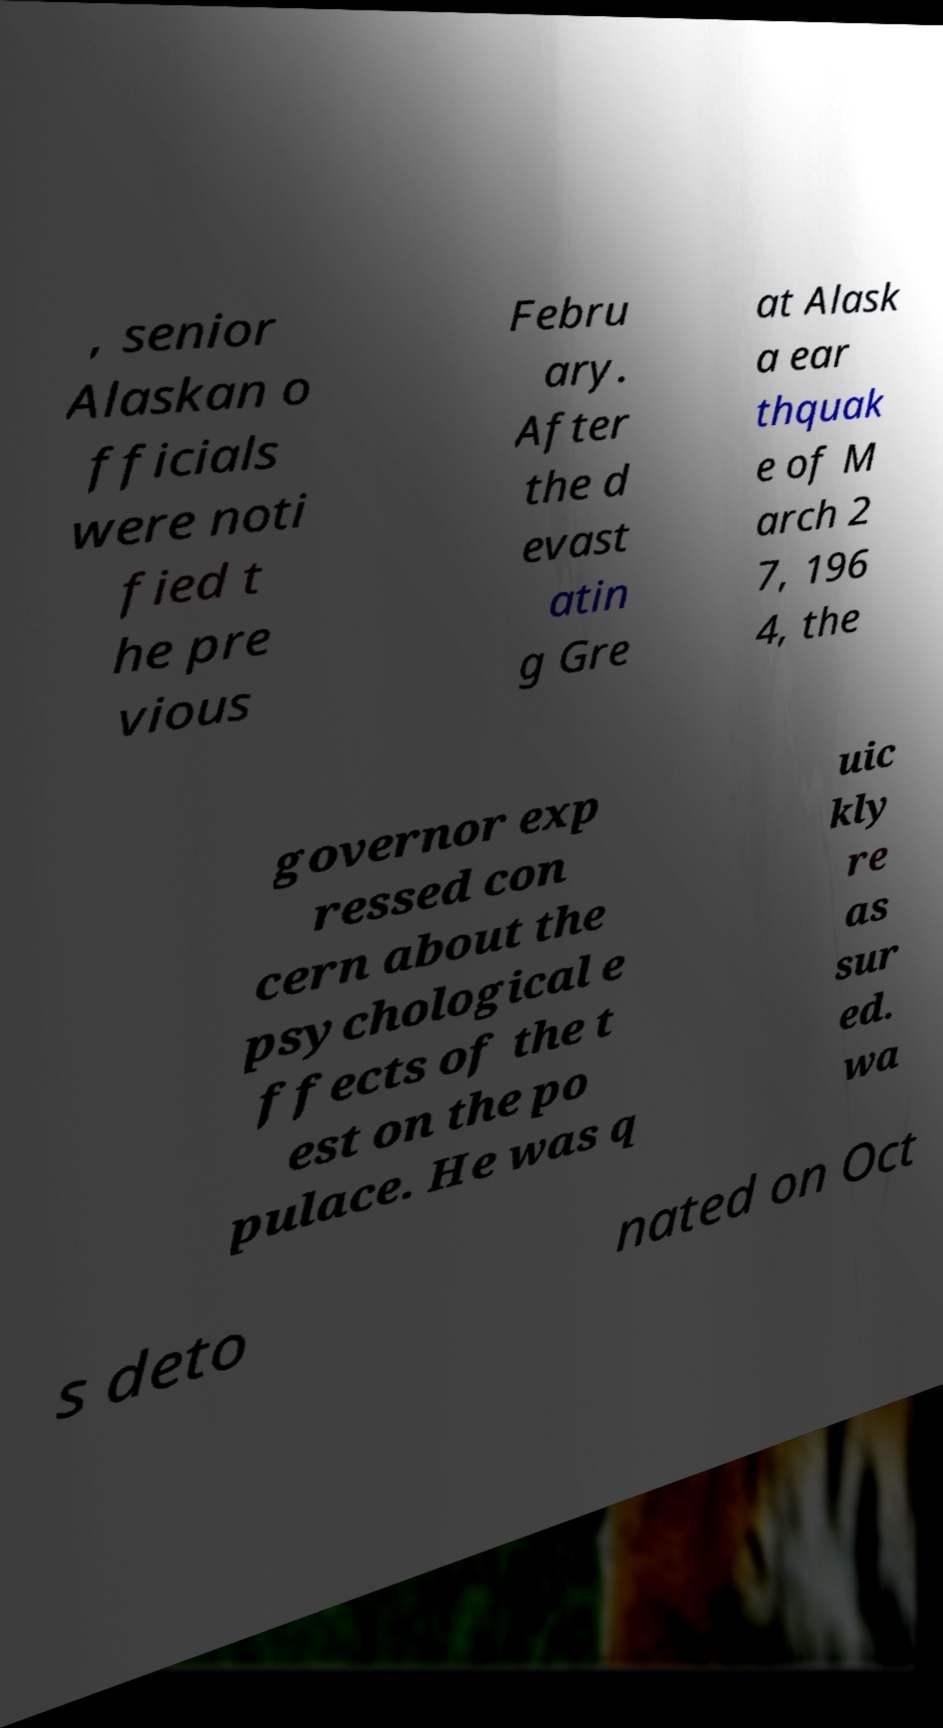Can you accurately transcribe the text from the provided image for me? , senior Alaskan o fficials were noti fied t he pre vious Febru ary. After the d evast atin g Gre at Alask a ear thquak e of M arch 2 7, 196 4, the governor exp ressed con cern about the psychological e ffects of the t est on the po pulace. He was q uic kly re as sur ed. wa s deto nated on Oct 